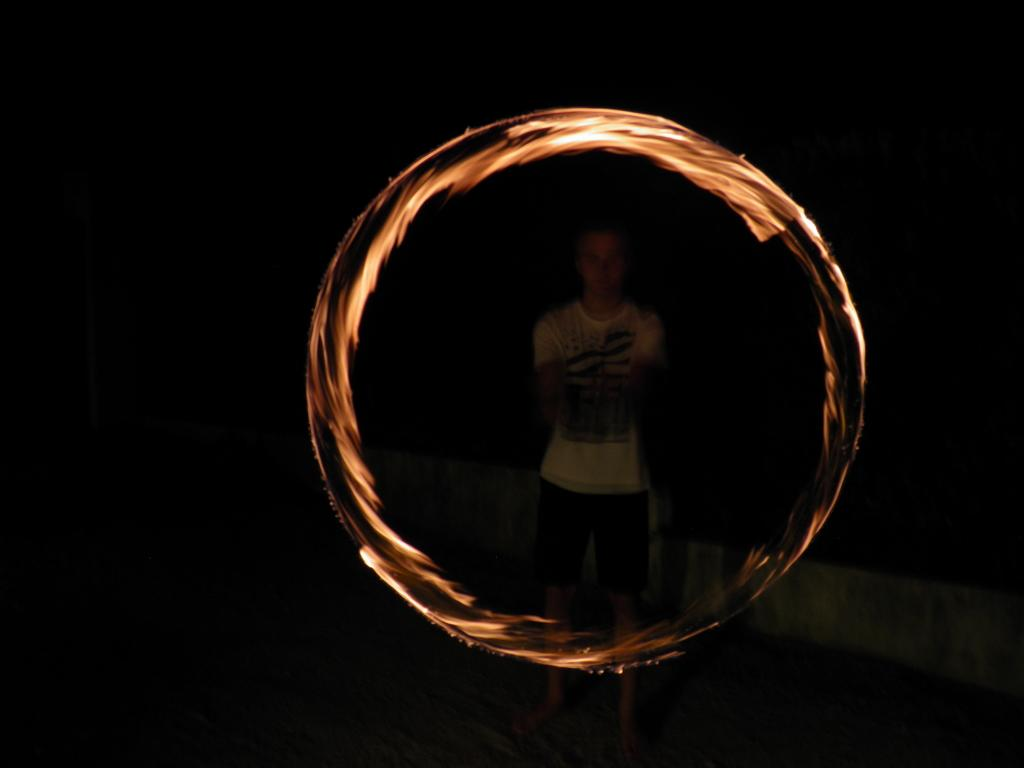What is the main subject of the image? There is a person standing in the image. What can be seen in the foreground of the image? There is a fire circle in the image. What is the color of the background in the image? The background of the image is dark. What type of spoon is being used to stir the eggnog in the image? There is no spoon or eggnog present in the image. How many cents are visible in the image? There are no cents visible in the image. 